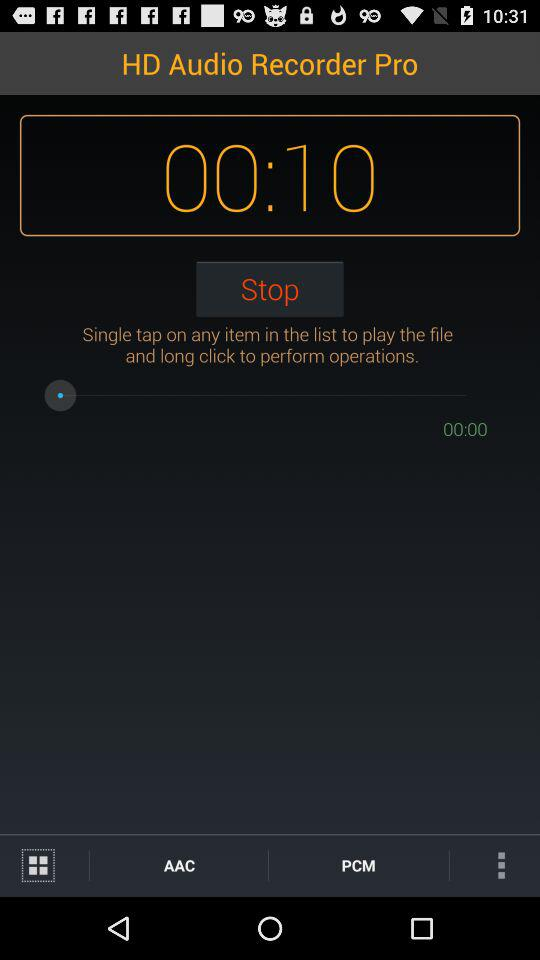How long is the recording?
Answer the question using a single word or phrase. 00:10 